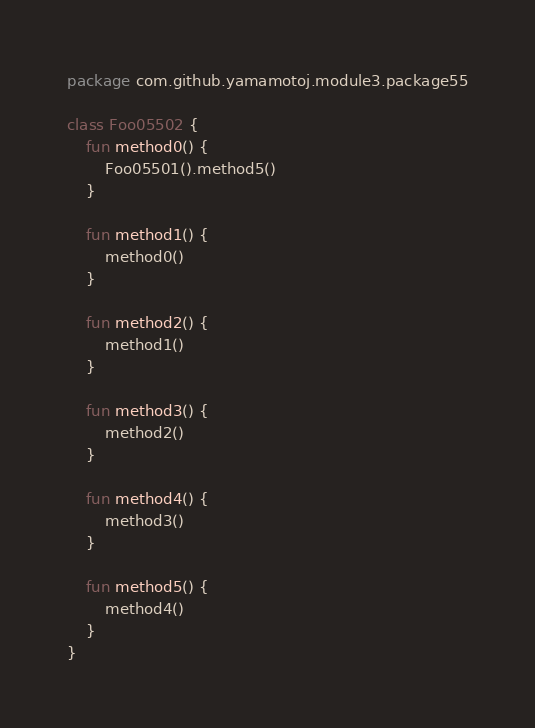Convert code to text. <code><loc_0><loc_0><loc_500><loc_500><_Kotlin_>package com.github.yamamotoj.module3.package55

class Foo05502 {
    fun method0() {
        Foo05501().method5()
    }

    fun method1() {
        method0()
    }

    fun method2() {
        method1()
    }

    fun method3() {
        method2()
    }

    fun method4() {
        method3()
    }

    fun method5() {
        method4()
    }
}
</code> 